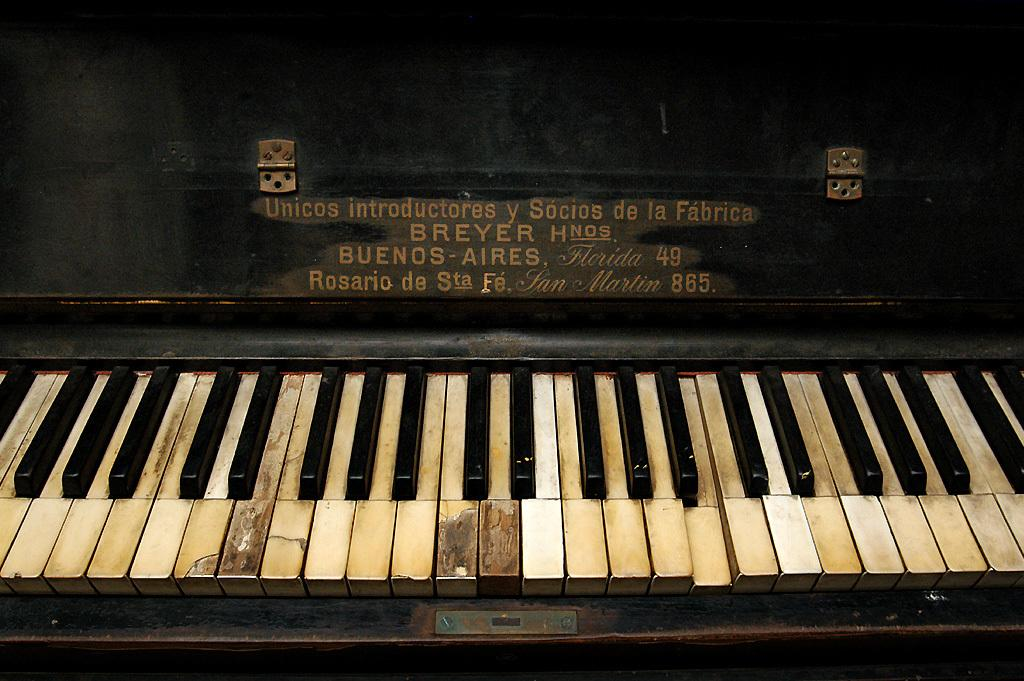What musical instrument is featured in the image? There is a piano keyboard in the image. How is the piano keyboard emphasized or distinguished in the image? The piano keyboard is highlighted in the image. What type of honey is being used to create a theory about the division of labor in the image? There is no honey, theory, or division of labor present in the image; it only features a highlighted piano keyboard. 